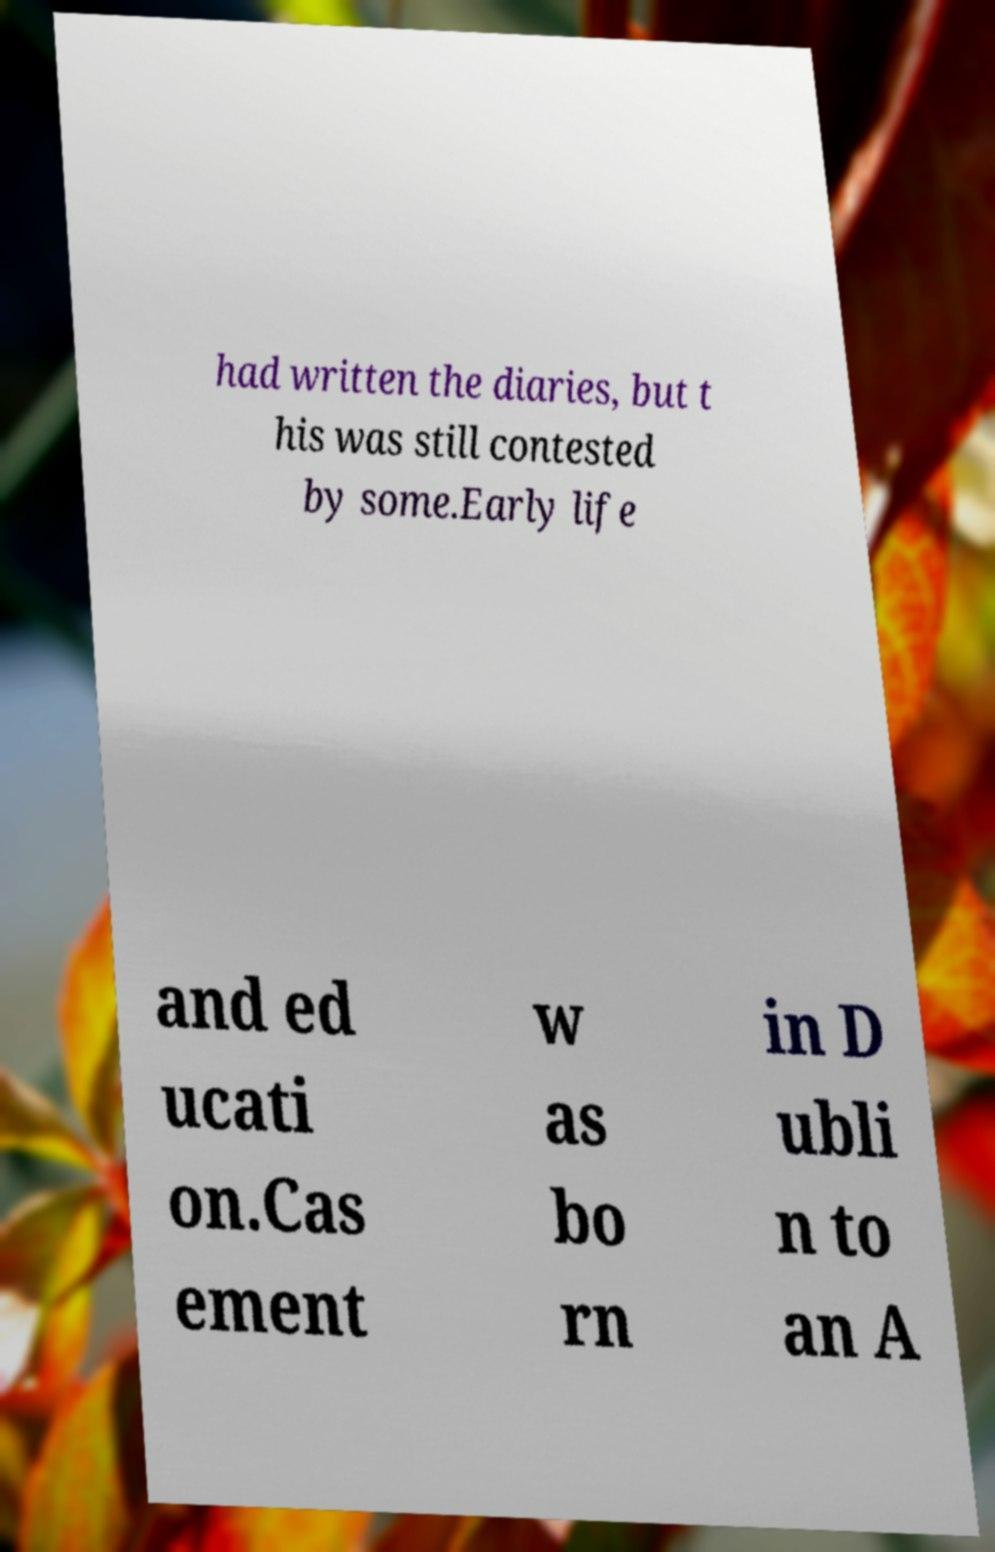What messages or text are displayed in this image? I need them in a readable, typed format. had written the diaries, but t his was still contested by some.Early life and ed ucati on.Cas ement w as bo rn in D ubli n to an A 